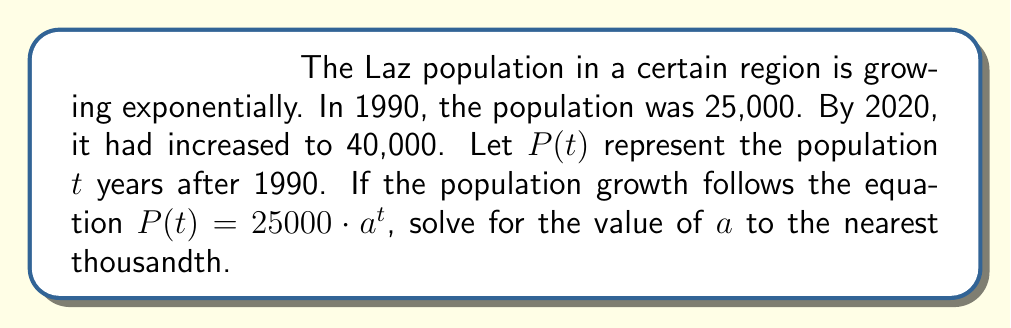Show me your answer to this math problem. To solve this problem, we'll use the given information and the exponential growth equation:

1) We know that $P(t) = 25000 \cdot a^t$, where $t$ is the number of years since 1990.

2) We have two data points:
   - In 1990 (t = 0): P(0) = 25,000
   - In 2020 (t = 30): P(30) = 40,000

3) Let's use the 2020 data point to set up an equation:
   $40000 = 25000 \cdot a^{30}$

4) Divide both sides by 25000:
   $\frac{40000}{25000} = a^{30}$

5) Simplify:
   $1.6 = a^{30}$

6) To solve for $a$, we need to take the 30th root of both sides:
   $a = \sqrt[30]{1.6}$

7) Using a calculator, we can compute this value:
   $a \approx 1.016$

8) Rounding to the nearest thousandth gives us 1.016.
Answer: $a \approx 1.016$ 